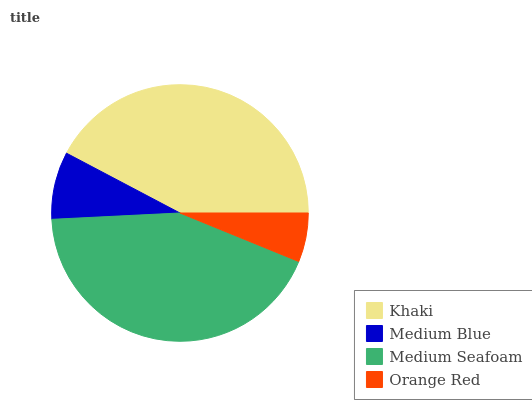Is Orange Red the minimum?
Answer yes or no. Yes. Is Medium Seafoam the maximum?
Answer yes or no. Yes. Is Medium Blue the minimum?
Answer yes or no. No. Is Medium Blue the maximum?
Answer yes or no. No. Is Khaki greater than Medium Blue?
Answer yes or no. Yes. Is Medium Blue less than Khaki?
Answer yes or no. Yes. Is Medium Blue greater than Khaki?
Answer yes or no. No. Is Khaki less than Medium Blue?
Answer yes or no. No. Is Khaki the high median?
Answer yes or no. Yes. Is Medium Blue the low median?
Answer yes or no. Yes. Is Orange Red the high median?
Answer yes or no. No. Is Orange Red the low median?
Answer yes or no. No. 